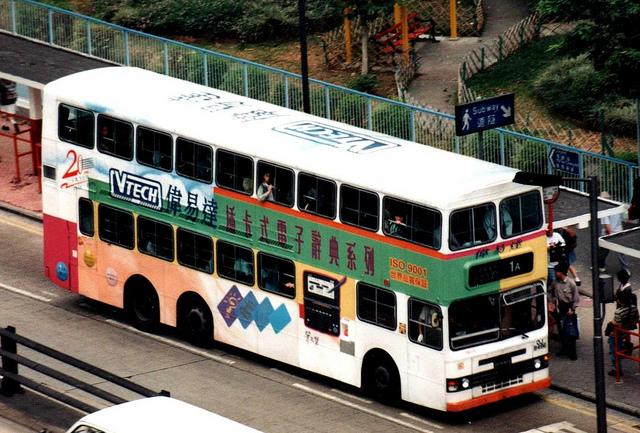On what side of the bus should they go if they want to take the metro? right 